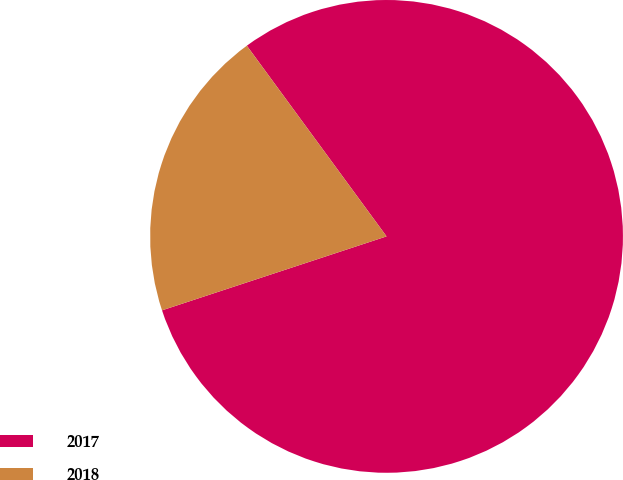Convert chart to OTSL. <chart><loc_0><loc_0><loc_500><loc_500><pie_chart><fcel>2017<fcel>2018<nl><fcel>80.0%<fcel>20.0%<nl></chart> 